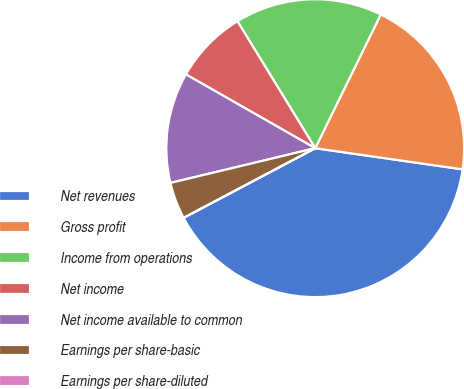<chart> <loc_0><loc_0><loc_500><loc_500><pie_chart><fcel>Net revenues<fcel>Gross profit<fcel>Income from operations<fcel>Net income<fcel>Net income available to common<fcel>Earnings per share-basic<fcel>Earnings per share-diluted<nl><fcel>39.99%<fcel>20.02%<fcel>16.0%<fcel>8.0%<fcel>12.0%<fcel>4.0%<fcel>0.0%<nl></chart> 